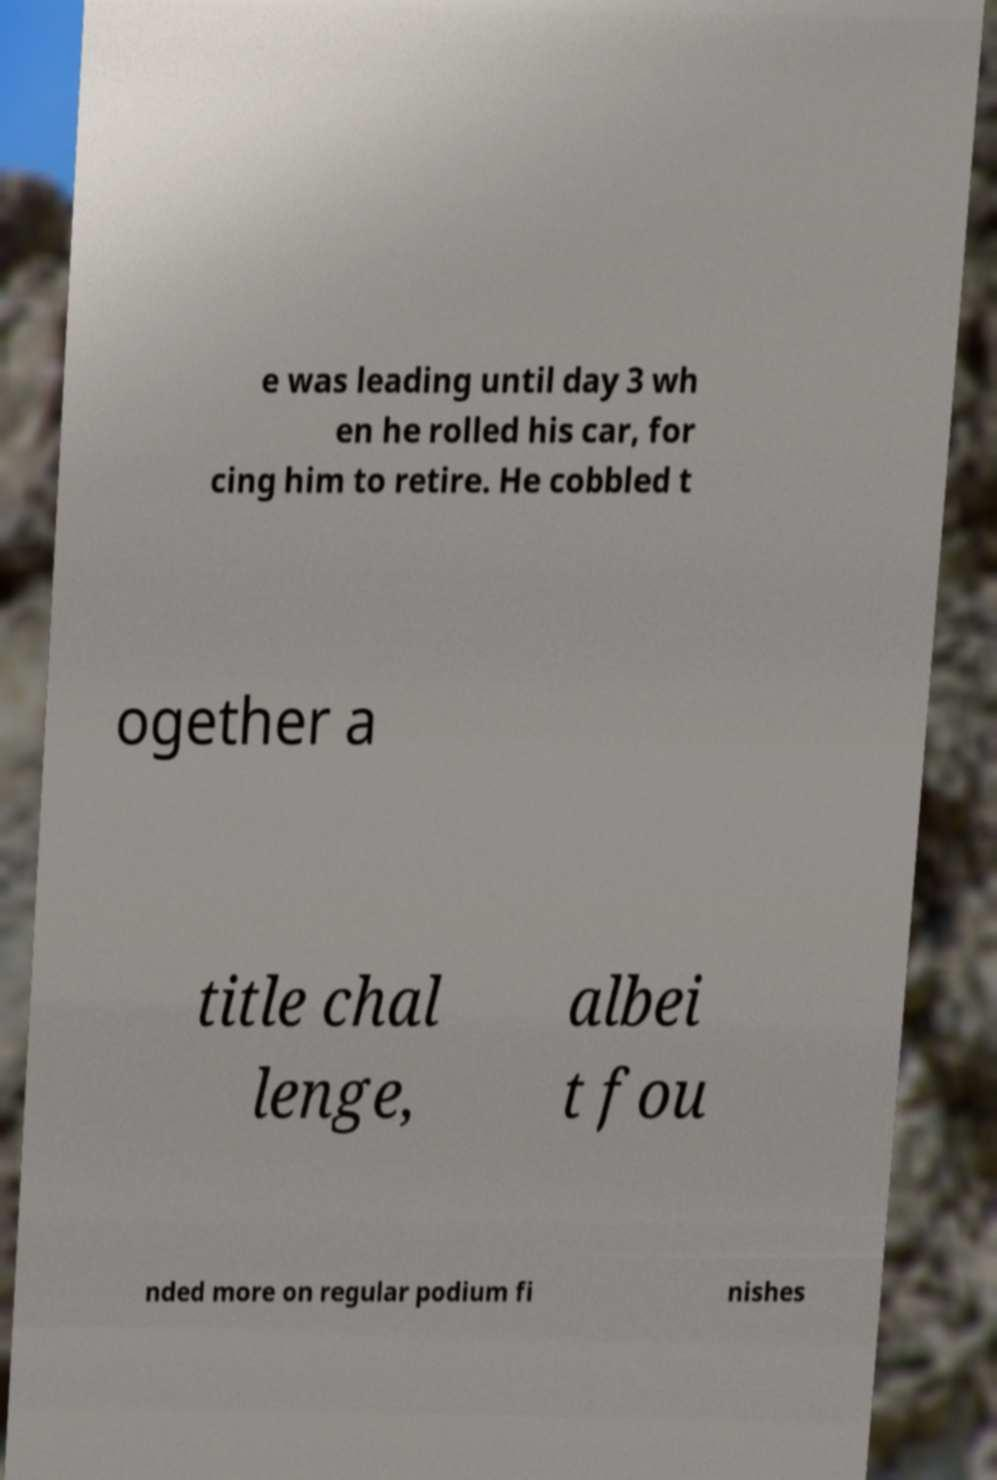What messages or text are displayed in this image? I need them in a readable, typed format. e was leading until day 3 wh en he rolled his car, for cing him to retire. He cobbled t ogether a title chal lenge, albei t fou nded more on regular podium fi nishes 